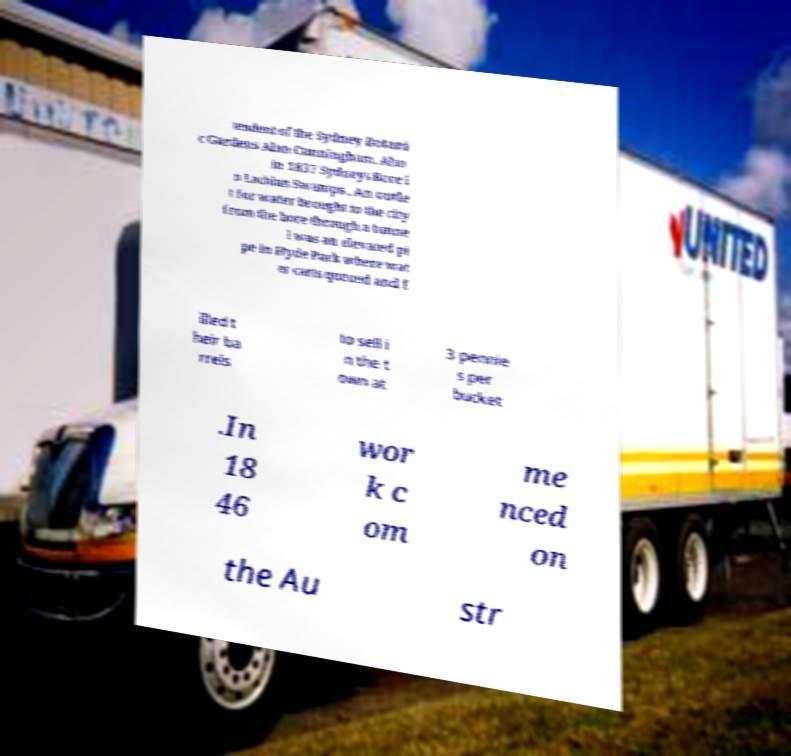Could you assist in decoding the text presented in this image and type it out clearly? tendent of the Sydney Botani c Gardens Alan Cunningham. Also in 1837 Sydneys Bore i n Lachlan Swamps . An outle t for water brought to the city from the bore through a tunne l was an elevated pi pe in Hyde Park where wat er carts queued and f illed t heir ba rrels to sell i n the t own at 3 pennie s per bucket .In 18 46 wor k c om me nced on the Au str 